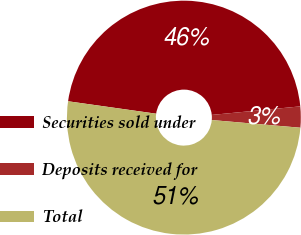<chart> <loc_0><loc_0><loc_500><loc_500><pie_chart><fcel>Securities sold under<fcel>Deposits received for<fcel>Total<nl><fcel>46.23%<fcel>2.91%<fcel>50.85%<nl></chart> 